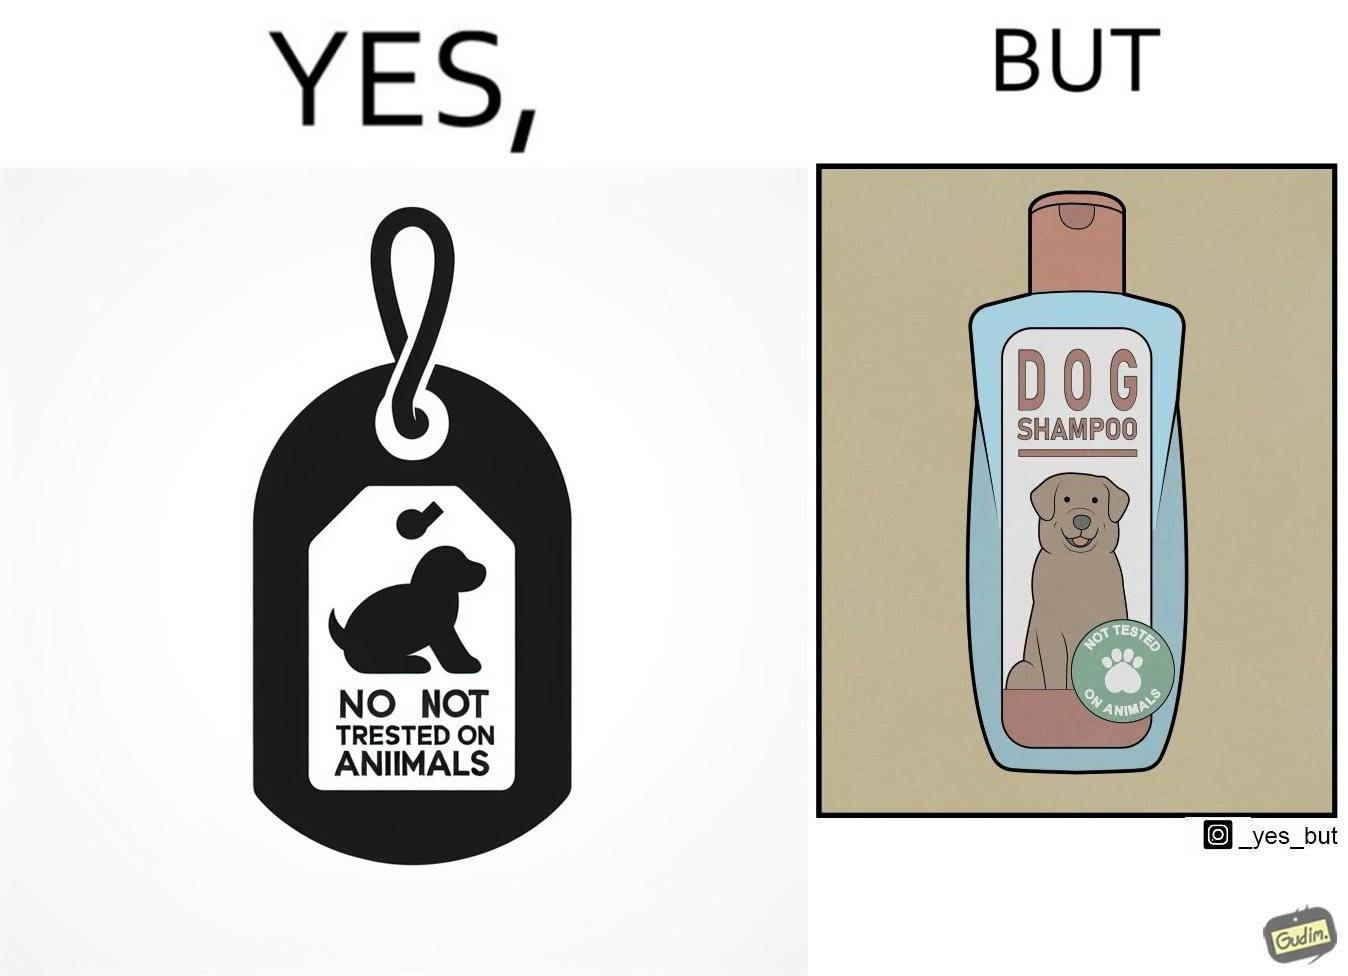Describe the contrast between the left and right parts of this image. In the left part of the image: It is a tag saying "not tested on animals" In the right part of the image: It is a dog shampoo bottle. 